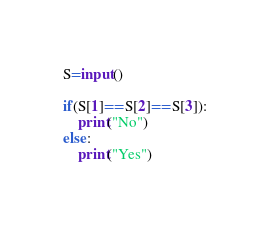Convert code to text. <code><loc_0><loc_0><loc_500><loc_500><_Python_>S=input()

if(S[1]==S[2]==S[3]):
    print("No")
else:
    print("Yes")
    </code> 